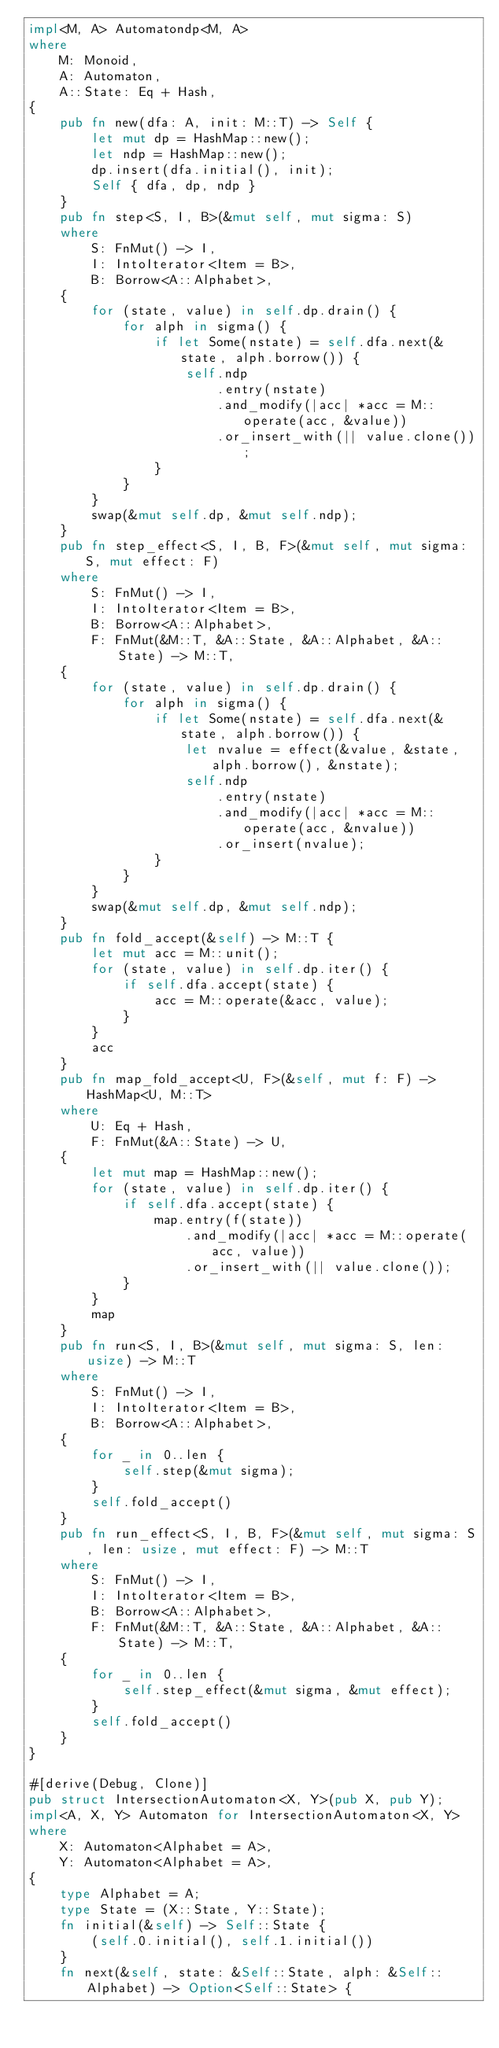Convert code to text. <code><loc_0><loc_0><loc_500><loc_500><_Rust_>impl<M, A> Automatondp<M, A>
where
    M: Monoid,
    A: Automaton,
    A::State: Eq + Hash,
{
    pub fn new(dfa: A, init: M::T) -> Self {
        let mut dp = HashMap::new();
        let ndp = HashMap::new();
        dp.insert(dfa.initial(), init);
        Self { dfa, dp, ndp }
    }
    pub fn step<S, I, B>(&mut self, mut sigma: S)
    where
        S: FnMut() -> I,
        I: IntoIterator<Item = B>,
        B: Borrow<A::Alphabet>,
    {
        for (state, value) in self.dp.drain() {
            for alph in sigma() {
                if let Some(nstate) = self.dfa.next(&state, alph.borrow()) {
                    self.ndp
                        .entry(nstate)
                        .and_modify(|acc| *acc = M::operate(acc, &value))
                        .or_insert_with(|| value.clone());
                }
            }
        }
        swap(&mut self.dp, &mut self.ndp);
    }
    pub fn step_effect<S, I, B, F>(&mut self, mut sigma: S, mut effect: F)
    where
        S: FnMut() -> I,
        I: IntoIterator<Item = B>,
        B: Borrow<A::Alphabet>,
        F: FnMut(&M::T, &A::State, &A::Alphabet, &A::State) -> M::T,
    {
        for (state, value) in self.dp.drain() {
            for alph in sigma() {
                if let Some(nstate) = self.dfa.next(&state, alph.borrow()) {
                    let nvalue = effect(&value, &state, alph.borrow(), &nstate);
                    self.ndp
                        .entry(nstate)
                        .and_modify(|acc| *acc = M::operate(acc, &nvalue))
                        .or_insert(nvalue);
                }
            }
        }
        swap(&mut self.dp, &mut self.ndp);
    }
    pub fn fold_accept(&self) -> M::T {
        let mut acc = M::unit();
        for (state, value) in self.dp.iter() {
            if self.dfa.accept(state) {
                acc = M::operate(&acc, value);
            }
        }
        acc
    }
    pub fn map_fold_accept<U, F>(&self, mut f: F) -> HashMap<U, M::T>
    where
        U: Eq + Hash,
        F: FnMut(&A::State) -> U,
    {
        let mut map = HashMap::new();
        for (state, value) in self.dp.iter() {
            if self.dfa.accept(state) {
                map.entry(f(state))
                    .and_modify(|acc| *acc = M::operate(acc, value))
                    .or_insert_with(|| value.clone());
            }
        }
        map
    }
    pub fn run<S, I, B>(&mut self, mut sigma: S, len: usize) -> M::T
    where
        S: FnMut() -> I,
        I: IntoIterator<Item = B>,
        B: Borrow<A::Alphabet>,
    {
        for _ in 0..len {
            self.step(&mut sigma);
        }
        self.fold_accept()
    }
    pub fn run_effect<S, I, B, F>(&mut self, mut sigma: S, len: usize, mut effect: F) -> M::T
    where
        S: FnMut() -> I,
        I: IntoIterator<Item = B>,
        B: Borrow<A::Alphabet>,
        F: FnMut(&M::T, &A::State, &A::Alphabet, &A::State) -> M::T,
    {
        for _ in 0..len {
            self.step_effect(&mut sigma, &mut effect);
        }
        self.fold_accept()
    }
}

#[derive(Debug, Clone)]
pub struct IntersectionAutomaton<X, Y>(pub X, pub Y);
impl<A, X, Y> Automaton for IntersectionAutomaton<X, Y>
where
    X: Automaton<Alphabet = A>,
    Y: Automaton<Alphabet = A>,
{
    type Alphabet = A;
    type State = (X::State, Y::State);
    fn initial(&self) -> Self::State {
        (self.0.initial(), self.1.initial())
    }
    fn next(&self, state: &Self::State, alph: &Self::Alphabet) -> Option<Self::State> {</code> 